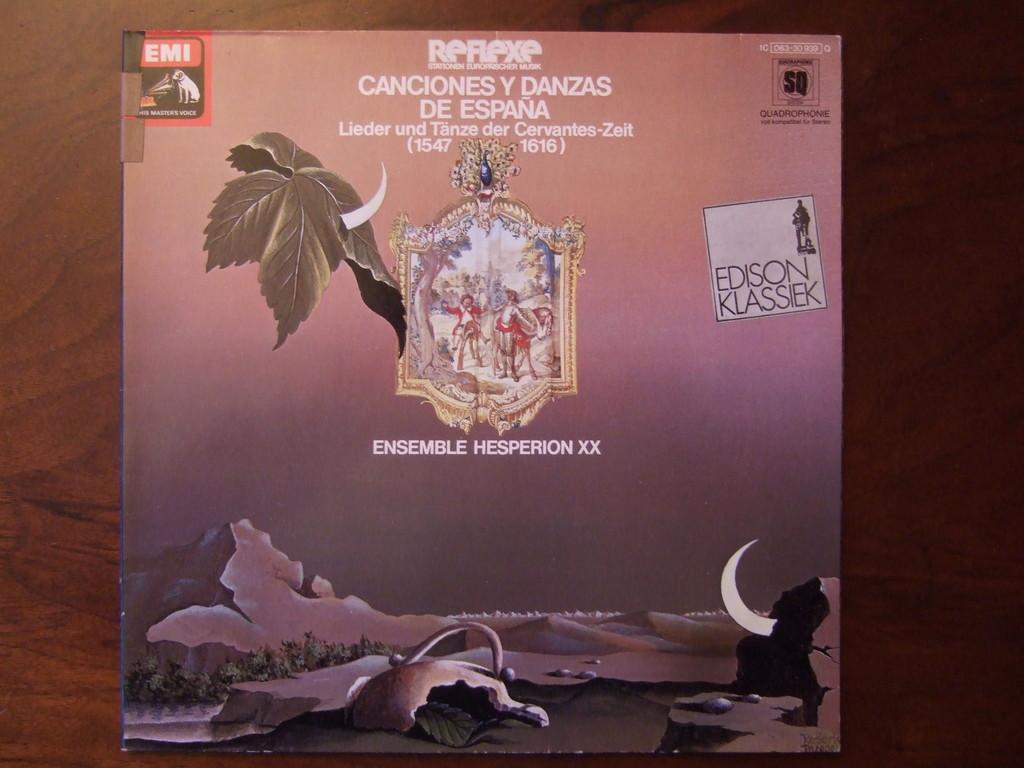In one or two sentences, can you explain what this image depicts? In this image I can see the brown colored surface and on it I can see a book. 